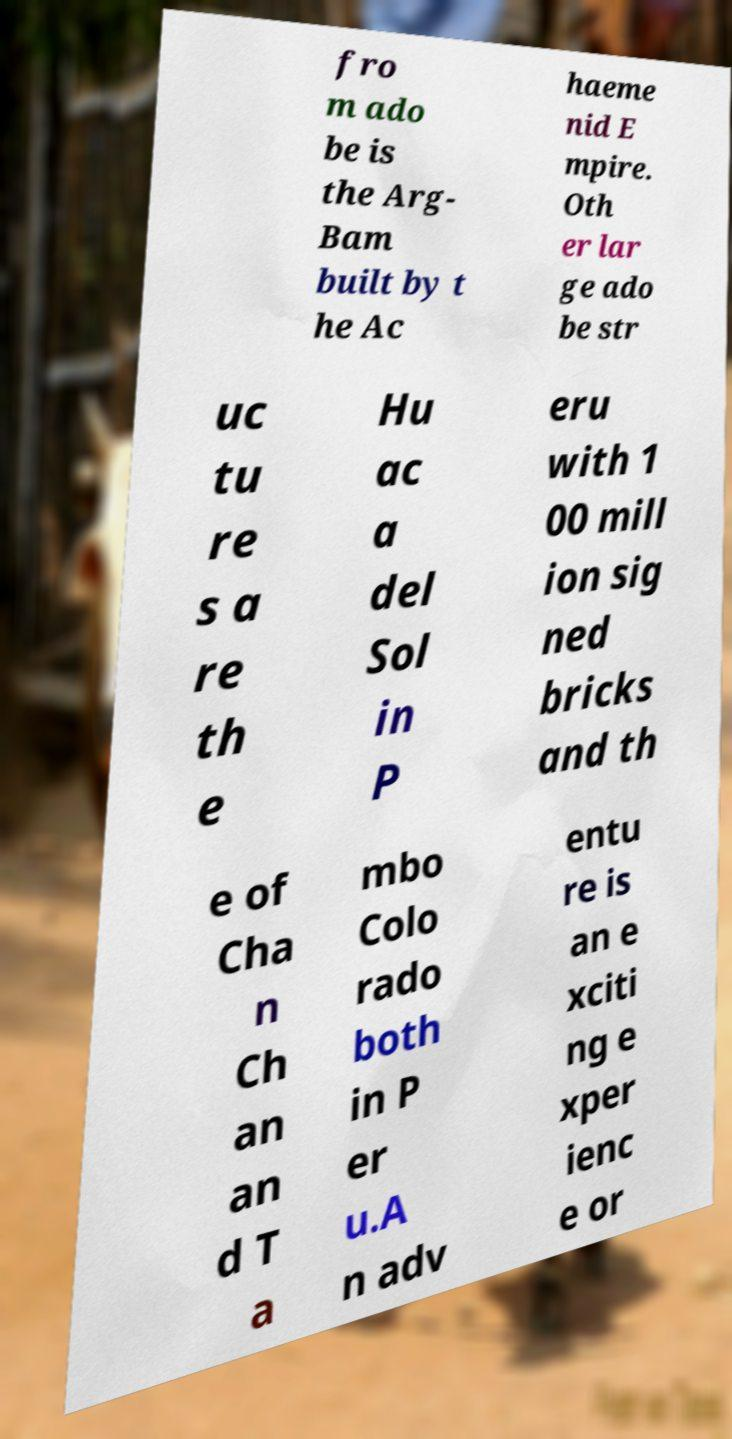What messages or text are displayed in this image? I need them in a readable, typed format. fro m ado be is the Arg- Bam built by t he Ac haeme nid E mpire. Oth er lar ge ado be str uc tu re s a re th e Hu ac a del Sol in P eru with 1 00 mill ion sig ned bricks and th e of Cha n Ch an an d T a mbo Colo rado both in P er u.A n adv entu re is an e xciti ng e xper ienc e or 